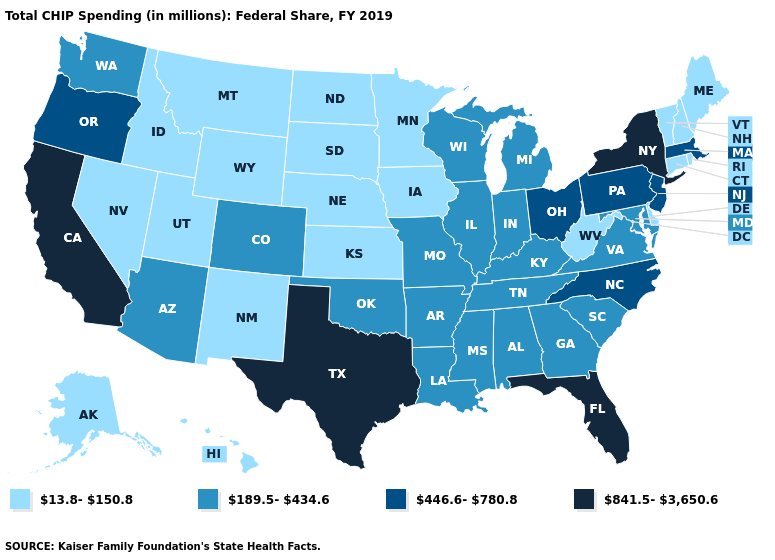What is the highest value in the USA?
Concise answer only. 841.5-3,650.6. What is the value of North Dakota?
Keep it brief. 13.8-150.8. What is the lowest value in the USA?
Quick response, please. 13.8-150.8. Which states have the lowest value in the USA?
Concise answer only. Alaska, Connecticut, Delaware, Hawaii, Idaho, Iowa, Kansas, Maine, Minnesota, Montana, Nebraska, Nevada, New Hampshire, New Mexico, North Dakota, Rhode Island, South Dakota, Utah, Vermont, West Virginia, Wyoming. Name the states that have a value in the range 13.8-150.8?
Write a very short answer. Alaska, Connecticut, Delaware, Hawaii, Idaho, Iowa, Kansas, Maine, Minnesota, Montana, Nebraska, Nevada, New Hampshire, New Mexico, North Dakota, Rhode Island, South Dakota, Utah, Vermont, West Virginia, Wyoming. What is the value of Ohio?
Write a very short answer. 446.6-780.8. Name the states that have a value in the range 189.5-434.6?
Quick response, please. Alabama, Arizona, Arkansas, Colorado, Georgia, Illinois, Indiana, Kentucky, Louisiana, Maryland, Michigan, Mississippi, Missouri, Oklahoma, South Carolina, Tennessee, Virginia, Washington, Wisconsin. What is the highest value in the MidWest ?
Concise answer only. 446.6-780.8. What is the value of Vermont?
Give a very brief answer. 13.8-150.8. What is the value of Connecticut?
Concise answer only. 13.8-150.8. What is the lowest value in the West?
Short answer required. 13.8-150.8. Does the map have missing data?
Write a very short answer. No. What is the value of Nevada?
Write a very short answer. 13.8-150.8. What is the lowest value in the West?
Answer briefly. 13.8-150.8. What is the lowest value in states that border Indiana?
Give a very brief answer. 189.5-434.6. 